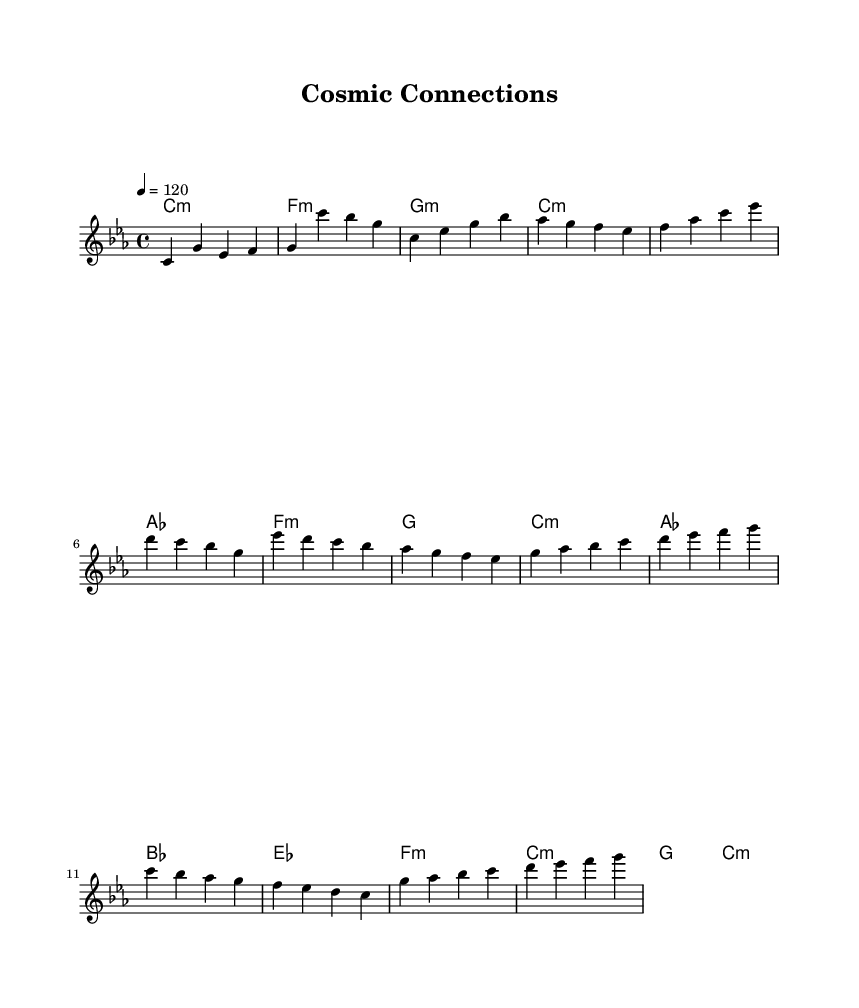What is the key signature of this music? The key signature indicated is C minor, which is represented by three flats in the context of the sheet music. This can be identified by the first measure where the key signature is shown.
Answer: C minor What is the time signature of this music? The time signature is shown at the beginning of the score, which is 4/4. This indicates there are four beats in every measure and a quarter note gets one beat.
Answer: 4/4 What is the tempo of this music? The tempo marking in the sheet music indicates 4 equals 120, which means there are 120 beats per minute. This can be observed near the beginning of the score where it states the tempo.
Answer: 120 How many measures are there in the melody? The melody section has 16 measures in total, counted by the vertical lines that denote the end of each measure throughout the given score.
Answer: 16 What is the chord played in the first measure? The chord in the first measure is C minor. This is identified in the chord names section where it indicates the chord name aligned with the melody notes.
Answer: C:m Which section contains the chorus? The chorus can be identified easily by looking for the repeated musical phrases typically placed after the verse, and in this case, it's the section starting with E flat in the melody.
Answer: Chorus What type of genre does this music represent? The use of electronic sounds, the structure of the melodies and harmonies, and the scientific themes imply that this composition can be categorized under electronic music with space-influenced sounds.
Answer: Electronic music 